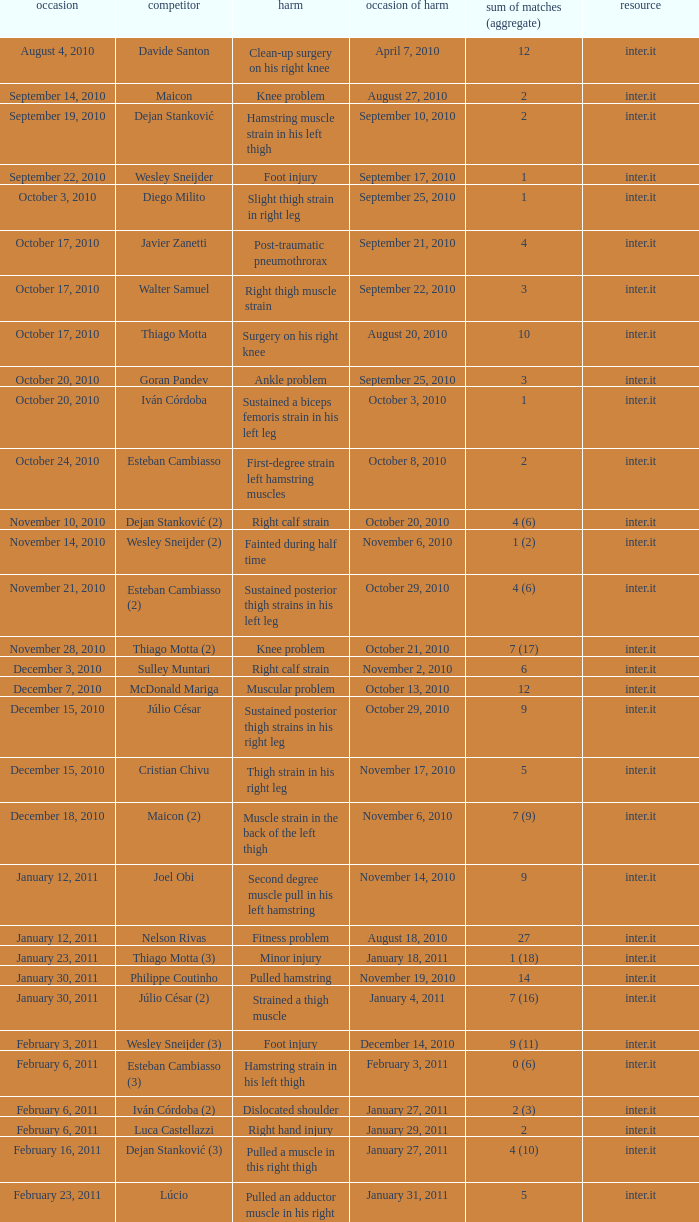What is the date of injury when the injury is foot injury and the number of matches (total) is 1? September 17, 2010. 